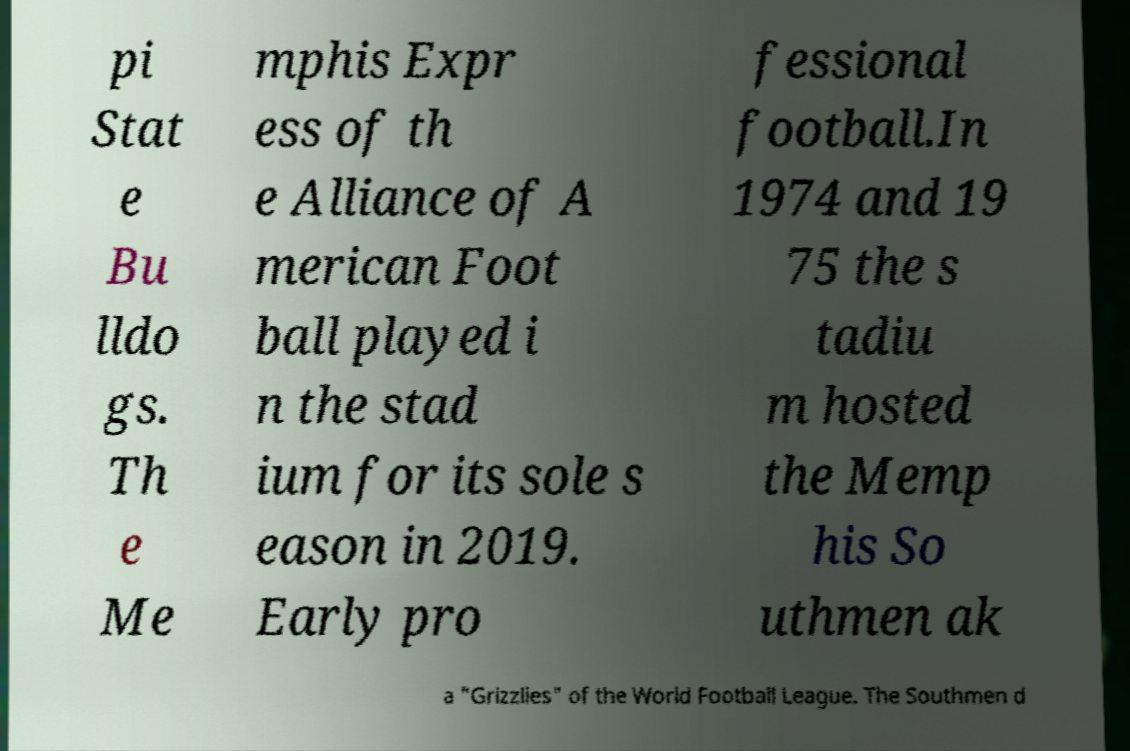There's text embedded in this image that I need extracted. Can you transcribe it verbatim? pi Stat e Bu lldo gs. Th e Me mphis Expr ess of th e Alliance of A merican Foot ball played i n the stad ium for its sole s eason in 2019. Early pro fessional football.In 1974 and 19 75 the s tadiu m hosted the Memp his So uthmen ak a "Grizzlies" of the World Football League. The Southmen d 